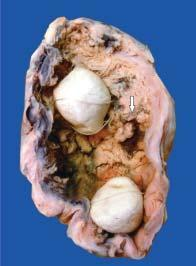what are also present in the lumen?
Answer the question using a single word or phrase. Two multi-faceted gallstones 